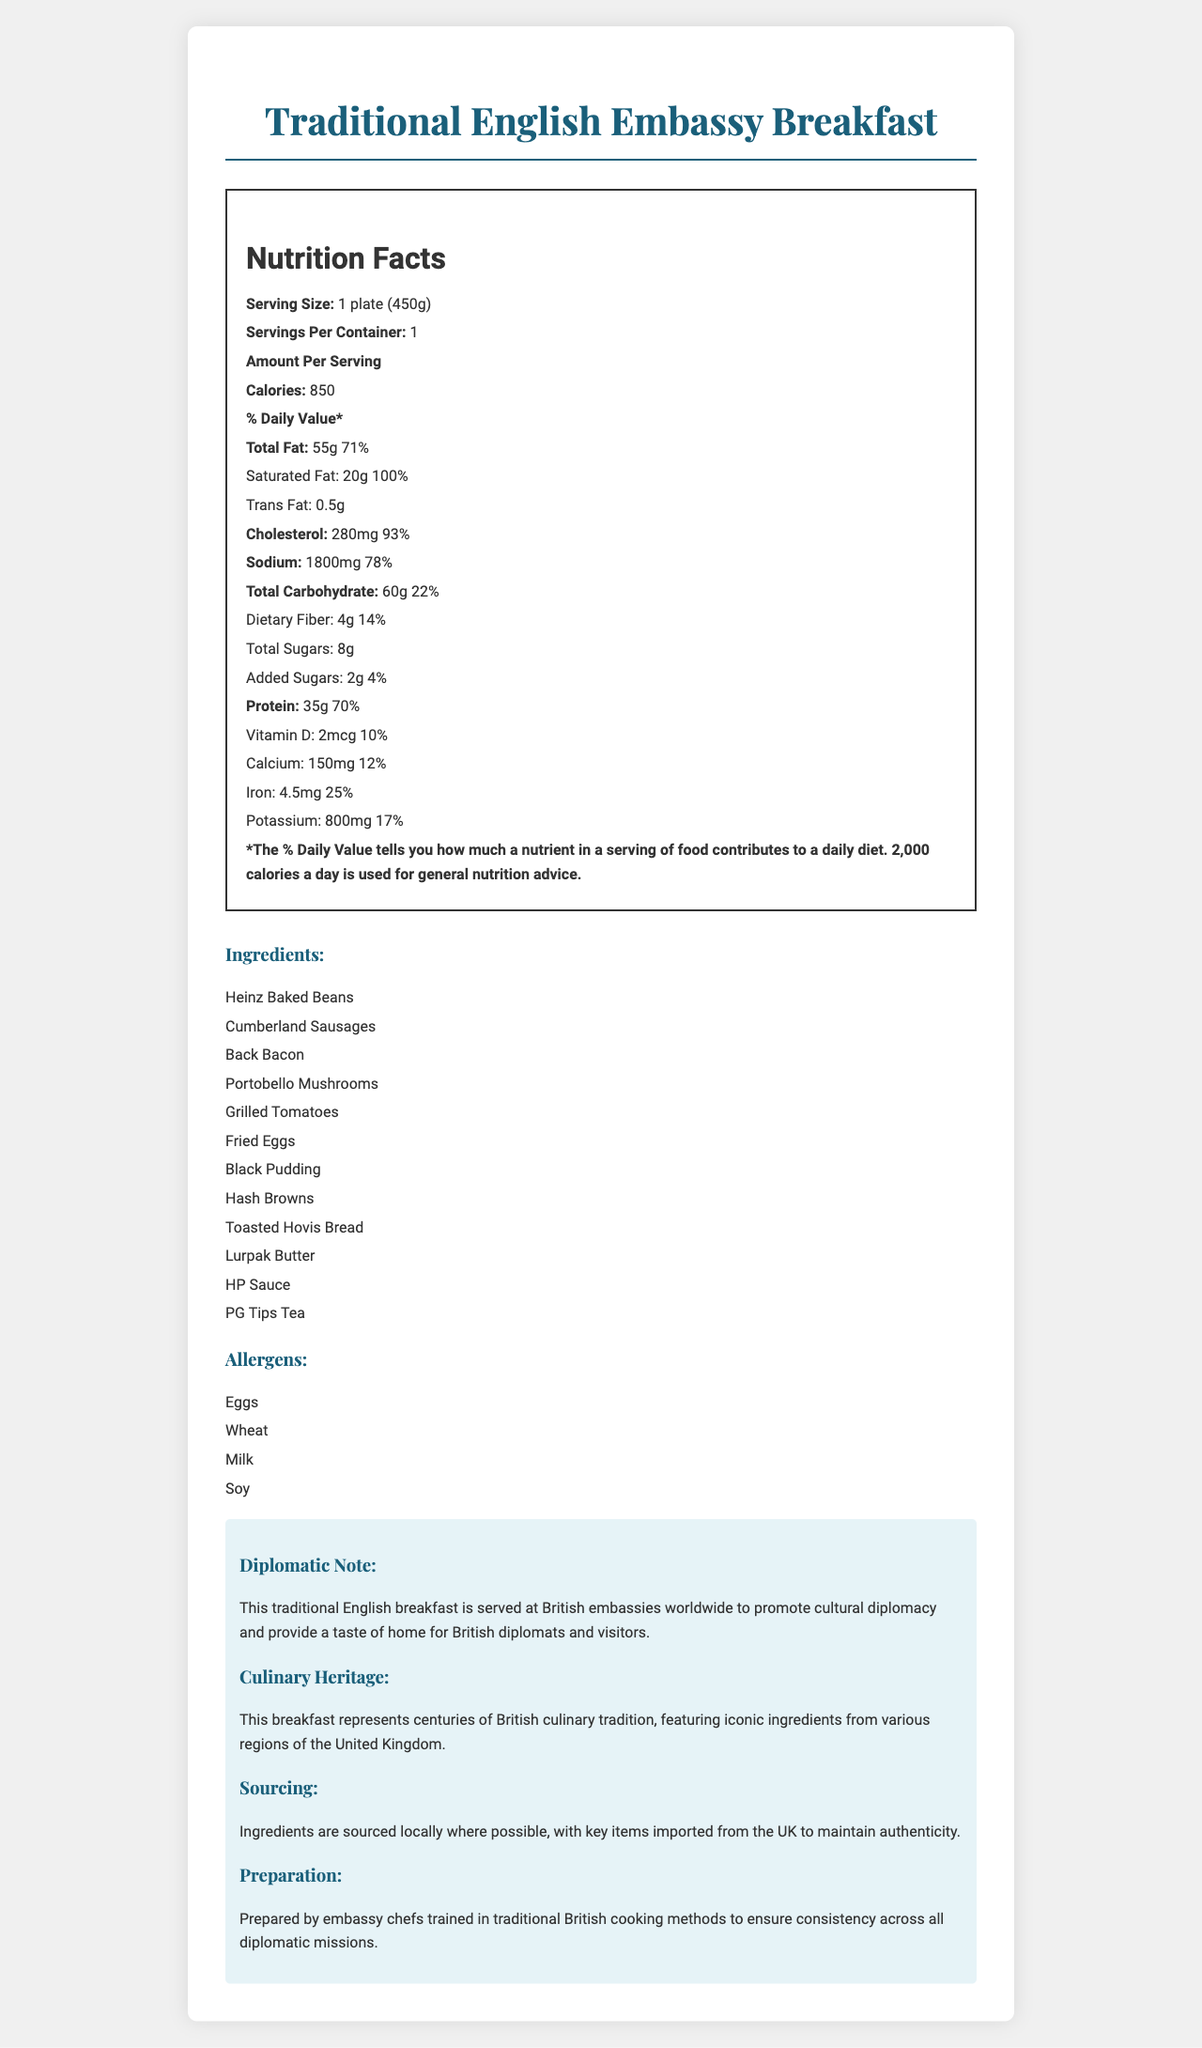what is the serving size for the Traditional English Embassy Breakfast? The serving size is listed as "1 plate (450g)" in the Nutrition Facts section.
Answer: 1 plate (450g) how many calories are in one serving? The number of calories per serving is listed as 850 in the Nutrition Facts section.
Answer: 850 what is the total fat content per serving? The total fat content per serving is listed as 55 grams in the Nutrition Facts section.
Answer: 55g what percentage of the daily value of cholesterol does one serving contain? The percentage of daily value for cholesterol is listed as 93% in the Nutrition Facts section.
Answer: 93% which allergen is NOT listed in the allergens section? A. Eggs B. Peanuts C. Milk D. Wheat The allergens section lists Eggs, Wheat, Milk, and Soy, but not Peanuts.
Answer: B. Peanuts what are the main protein sources in this breakfast? The main protein sources are Cumberland Sausages, Back Bacon, Fried Eggs, and Black Pudding as listed in the ingredients.
Answer: Cumberland Sausages, Back Bacon, Fried Eggs, Black Pudding what is the daily value percentage of dietary fiber in one serving? The daily value percentage for dietary fiber is listed as 14% in the Nutrition Facts section.
Answer: 14% which ingredient is used for tea? The ingredient used for tea is PG Tips Tea as listed in the ingredients section.
Answer: PG Tips Tea what is the diplomatic note about this breakfast? The diplomatic note states that the breakfast is served at British embassies worldwide to promote cultural diplomacy and provide a taste of home.
Answer: This traditional English breakfast is served at British embassies worldwide to promote cultural diplomacy and provide a taste of home for British diplomats and visitors. what beverages are mentioned in the ingredients? A. Heinz Baked Beans B. PG Tips Tea C. HP Sauce D. Grilled Tomatoes The ingredients list includes PG Tips Tea as the beverage.
Answer: B. PG Tips Tea is the preparation of this breakfast consistent across diplomatic missions? The Preparation section states that the breakfast is prepared by embassy chefs trained in traditional British cooking methods to ensure consistency.
Answer: Yes describe the main idea of the document. The document summarizes the nutritional facts, cultural relevance, ingredient sourcing, and preparation details of the Traditional English Embassy Breakfast, emphasizing its role in cultural diplomacy.
Answer: Summary: The document provides nutritional information, ingredients, allergens, and additional details about the Traditional English Embassy Breakfast served at British embassies worldwide. It highlights the nutritional values, cultural significance, ingredient sourcing, and preparation methods. how many milligrams of sodium does one serving contain? The sodium content per serving is listed as 1800 milligrams in the Nutrition Facts section.
Answer: 1800mg what is the main purpose of serving this breakfast at British embassies? A. Promote British culinary traditions B. Provide a high-calorie meal C. Offer a variety of proteins D. Encourage dietary fiber intake The document explains that the breakfast is served at British embassies to promote cultural diplomacy and British culinary traditions.
Answer: A. Promote British culinary traditions what is the vitamin D content in one serving? The vitamin D content per serving is listed as 2 micrograms in the Nutrition Facts section.
Answer: 2mcg which information cannot be determined from the document? The document does not provide any information about the cost of the breakfast.
Answer: The cost of the Traditional English Embassy Breakfast what is the daily value percentage of saturated fat in one serving? The daily value percentage for saturated fat is listed as 100% in the Nutrition Facts section.
Answer: 100% 